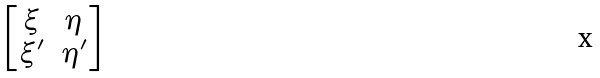<formula> <loc_0><loc_0><loc_500><loc_500>\begin{bmatrix} \xi & \eta \\ \xi ^ { \prime } & \eta ^ { \prime } \end{bmatrix}</formula> 